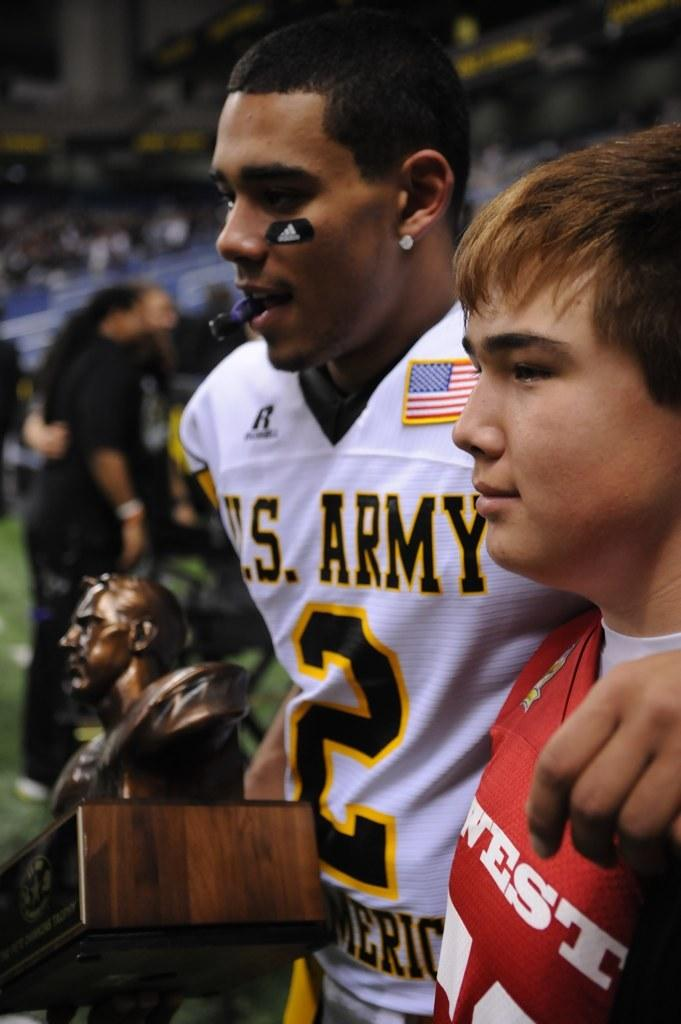<image>
Summarize the visual content of the image. A player with a US Army #2 jersey on has an arm around a youngster. 